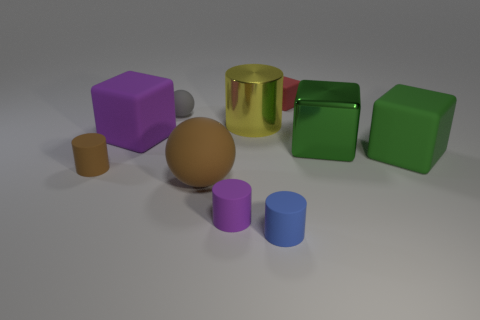Subtract all rubber blocks. How many blocks are left? 1 Subtract 1 spheres. How many spheres are left? 1 Subtract all gray balls. How many balls are left? 1 Subtract all yellow cubes. How many purple cylinders are left? 1 Subtract all big cyan shiny cubes. Subtract all blue cylinders. How many objects are left? 9 Add 3 small brown matte cylinders. How many small brown matte cylinders are left? 4 Add 4 rubber blocks. How many rubber blocks exist? 7 Subtract 0 red balls. How many objects are left? 10 Subtract all cylinders. How many objects are left? 6 Subtract all blue balls. Subtract all blue blocks. How many balls are left? 2 